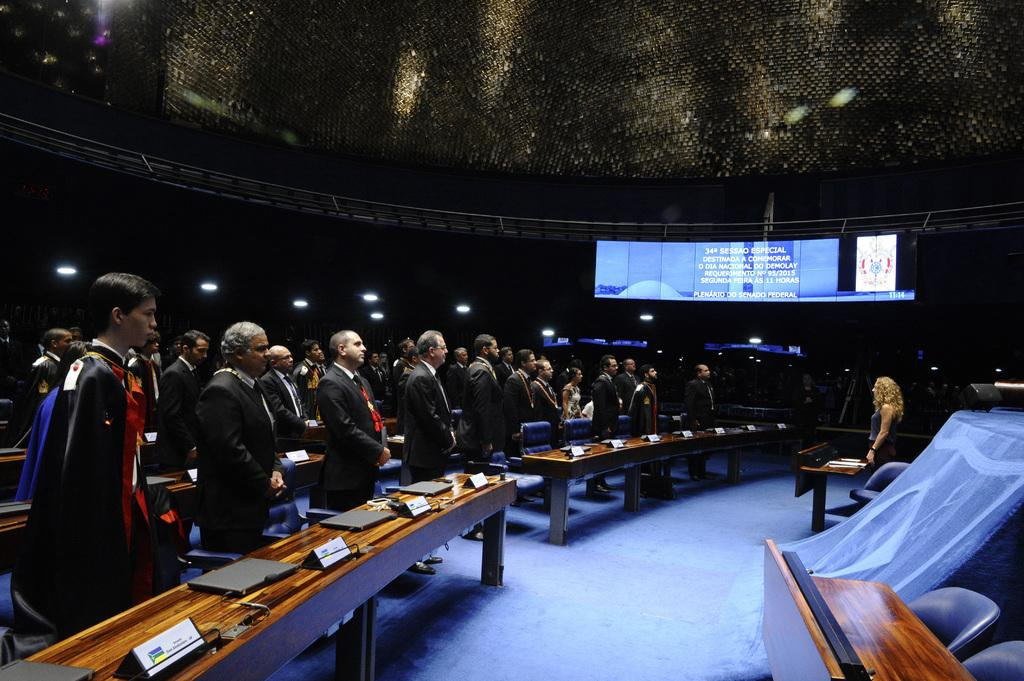What is the main subject of the image? The main subject of the image is people standing. Where are the people located in the image? The people are on the left side of the image. Is there any furniture or objects visible in the image? Yes, there is a table in the bottom right hand corner of the image. What type of flame can be seen on the table in the image? There is no flame present on the table in the image. What religious symbols are visible in the image? There are no religious symbols visible in the image. 